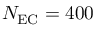Convert formula to latex. <formula><loc_0><loc_0><loc_500><loc_500>N _ { E C } = 4 0 0</formula> 